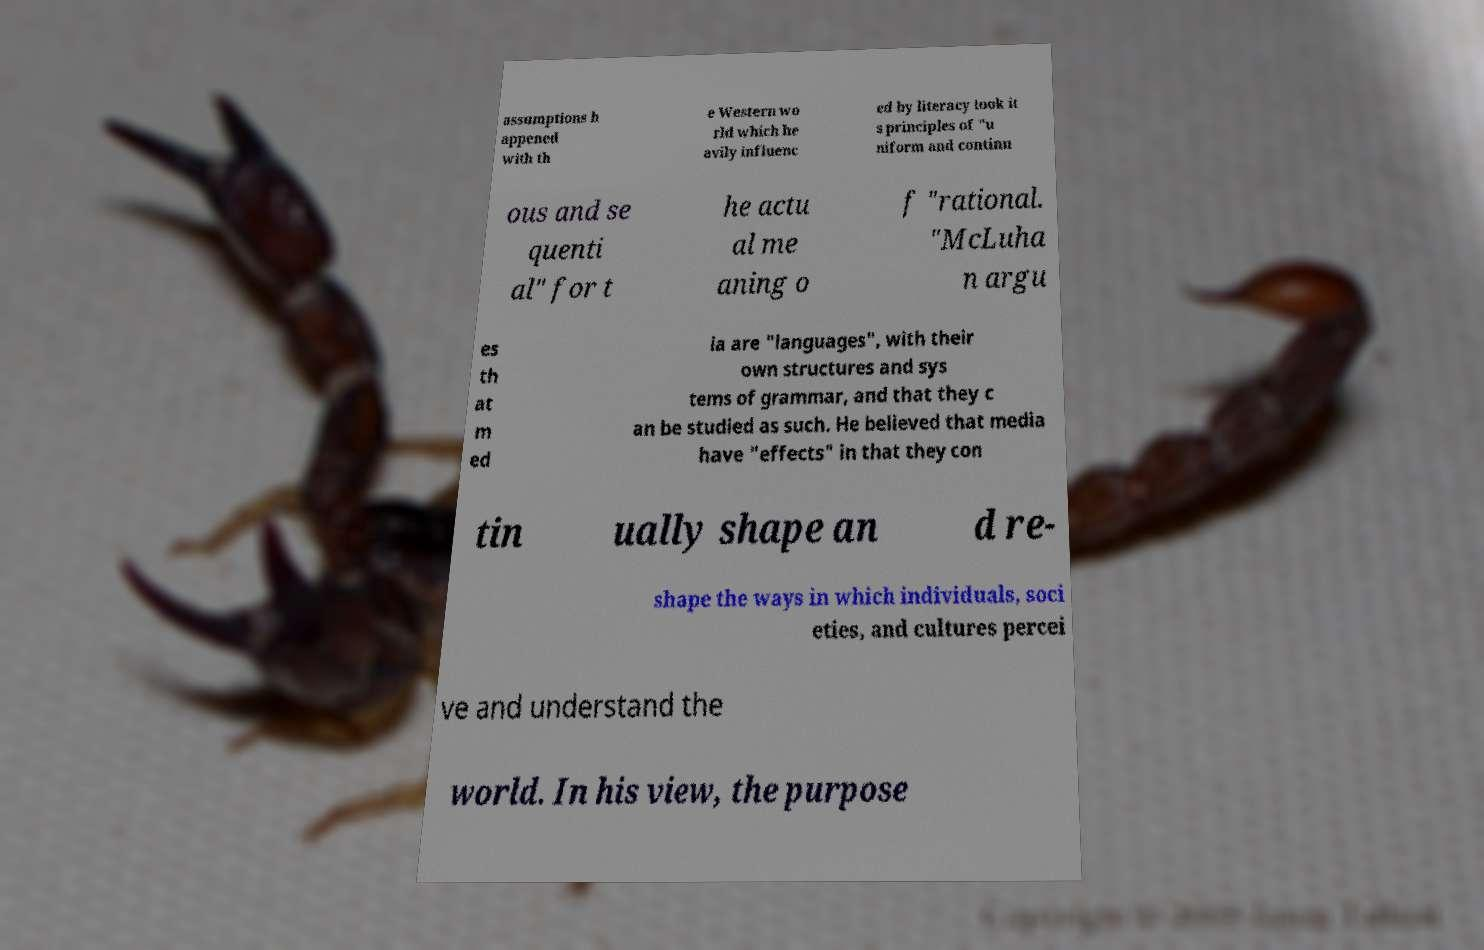Could you assist in decoding the text presented in this image and type it out clearly? assumptions h appened with th e Western wo rld which he avily influenc ed by literacy took it s principles of "u niform and continu ous and se quenti al" for t he actu al me aning o f "rational. "McLuha n argu es th at m ed ia are "languages", with their own structures and sys tems of grammar, and that they c an be studied as such. He believed that media have "effects" in that they con tin ually shape an d re- shape the ways in which individuals, soci eties, and cultures percei ve and understand the world. In his view, the purpose 